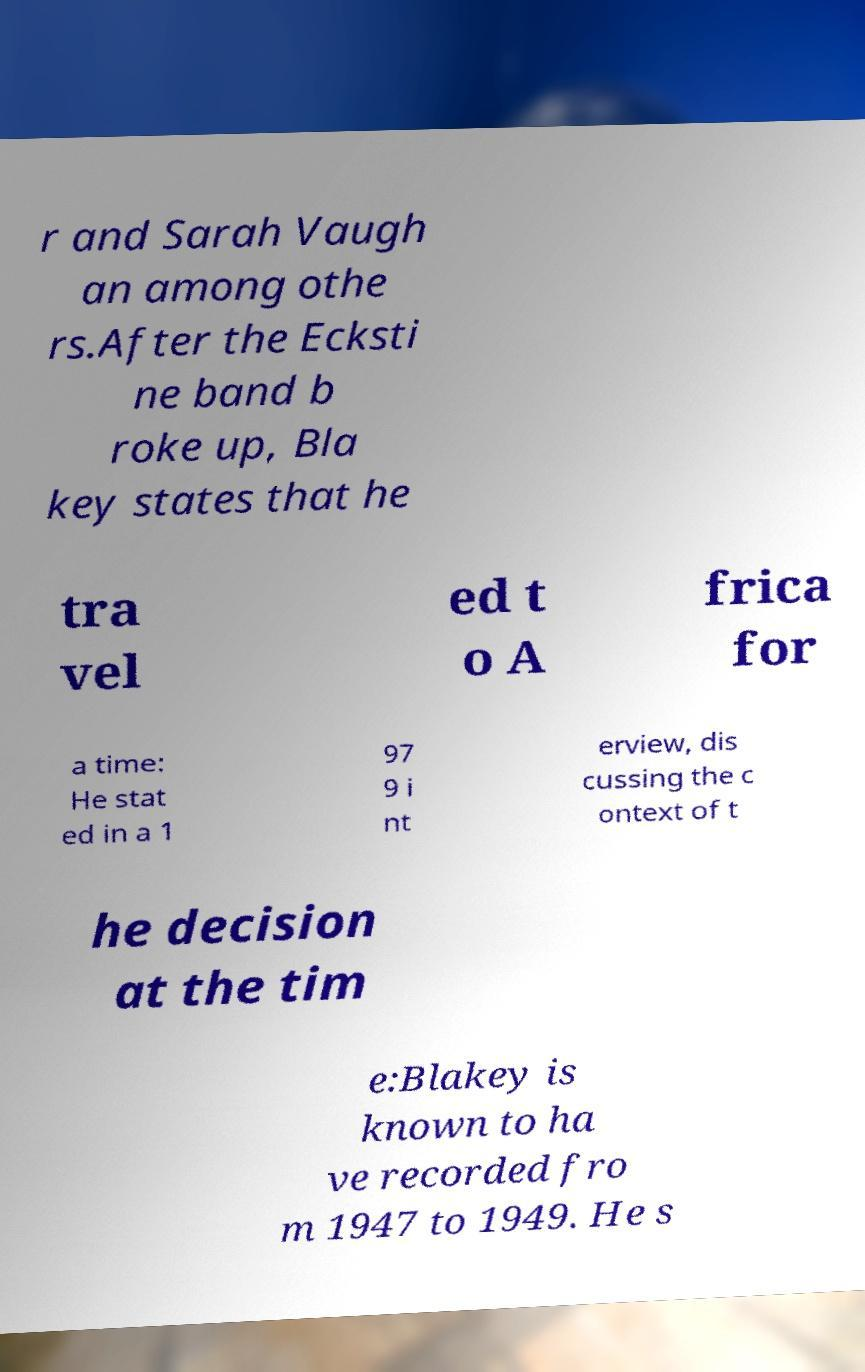Can you accurately transcribe the text from the provided image for me? r and Sarah Vaugh an among othe rs.After the Ecksti ne band b roke up, Bla key states that he tra vel ed t o A frica for a time: He stat ed in a 1 97 9 i nt erview, dis cussing the c ontext of t he decision at the tim e:Blakey is known to ha ve recorded fro m 1947 to 1949. He s 